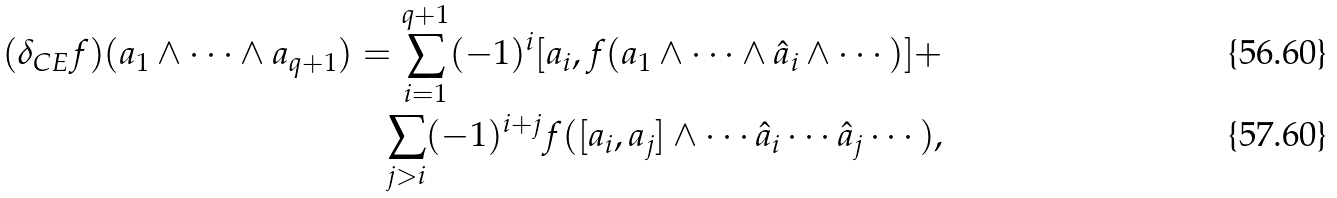Convert formula to latex. <formula><loc_0><loc_0><loc_500><loc_500>( \delta _ { C E } f ) ( a _ { 1 } \wedge \cdots \wedge a _ { q + 1 } ) = \sum _ { i = 1 } ^ { q + 1 } ( - 1 ) ^ { i } [ a _ { i } , f ( a _ { 1 } \wedge \cdots \wedge \hat { a } _ { i } \wedge \cdots ) ] + \\ \sum _ { j > i } ( - 1 ) ^ { i + j } f ( [ a _ { i } , a _ { j } ] \wedge \cdots \hat { a } _ { i } \cdots \hat { a } _ { j } \cdots ) ,</formula> 